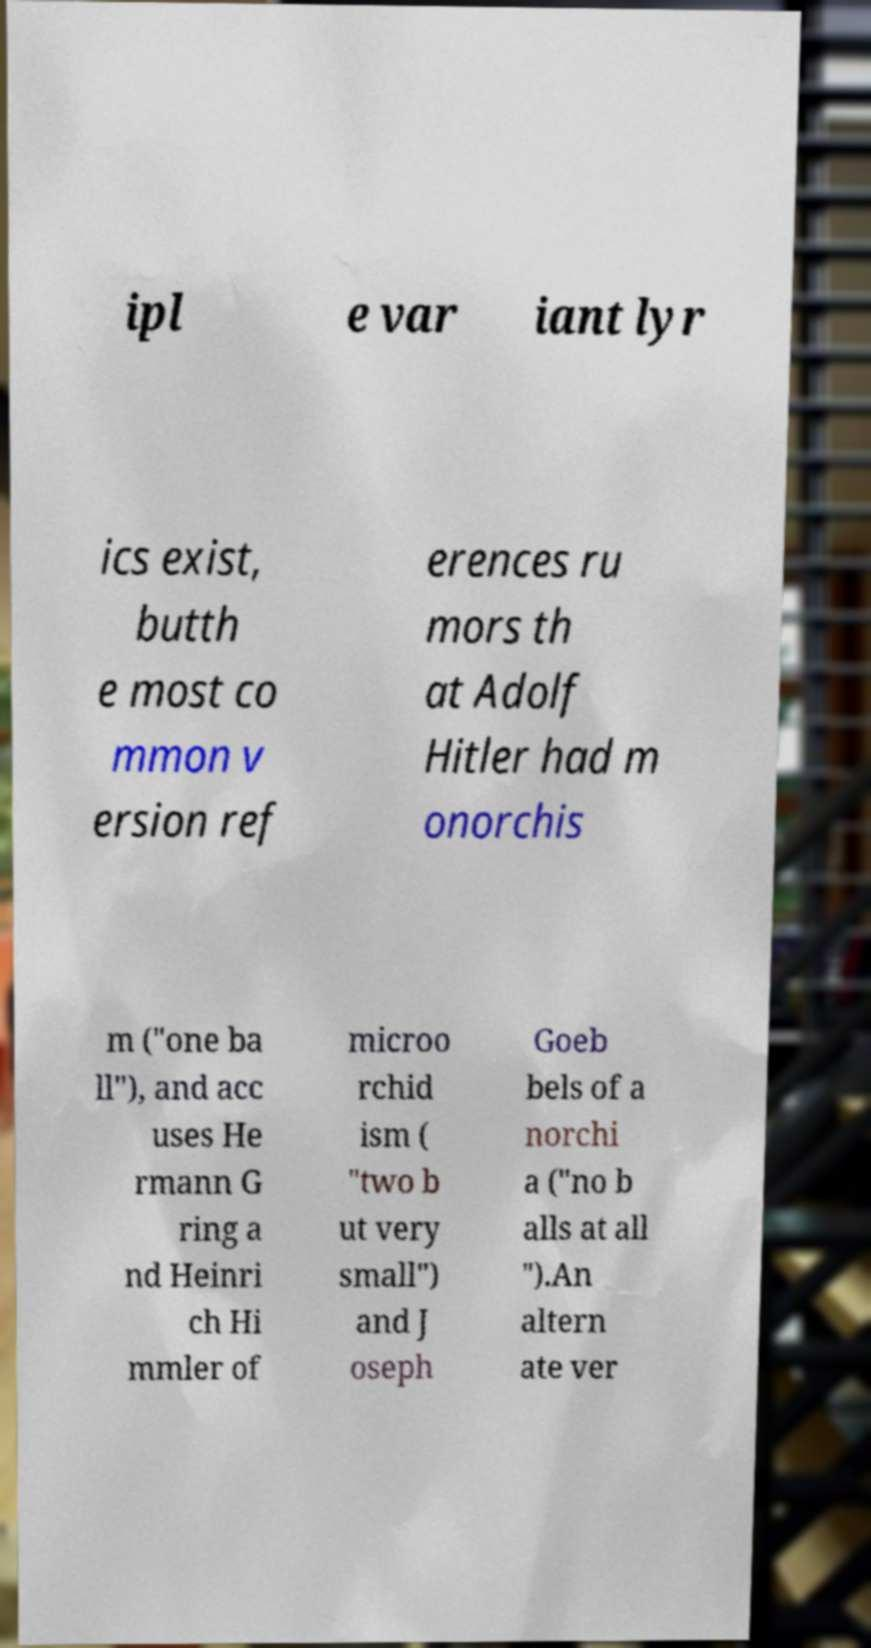Please read and relay the text visible in this image. What does it say? ipl e var iant lyr ics exist, butth e most co mmon v ersion ref erences ru mors th at Adolf Hitler had m onorchis m ("one ba ll"), and acc uses He rmann G ring a nd Heinri ch Hi mmler of microo rchid ism ( "two b ut very small") and J oseph Goeb bels of a norchi a ("no b alls at all ").An altern ate ver 